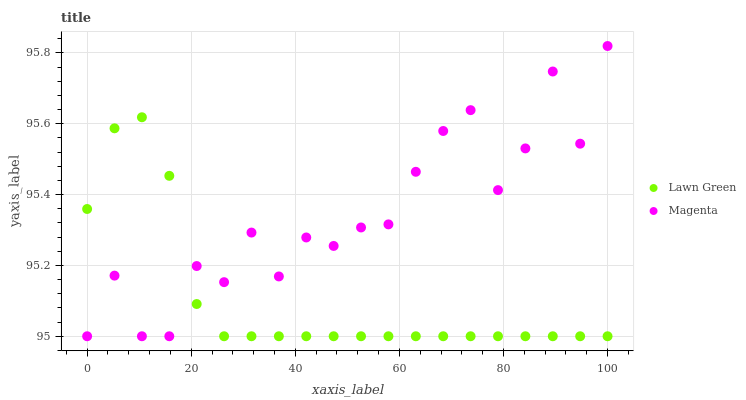Does Lawn Green have the minimum area under the curve?
Answer yes or no. Yes. Does Magenta have the maximum area under the curve?
Answer yes or no. Yes. Does Magenta have the minimum area under the curve?
Answer yes or no. No. Is Lawn Green the smoothest?
Answer yes or no. Yes. Is Magenta the roughest?
Answer yes or no. Yes. Is Magenta the smoothest?
Answer yes or no. No. Does Lawn Green have the lowest value?
Answer yes or no. Yes. Does Magenta have the highest value?
Answer yes or no. Yes. Does Magenta intersect Lawn Green?
Answer yes or no. Yes. Is Magenta less than Lawn Green?
Answer yes or no. No. Is Magenta greater than Lawn Green?
Answer yes or no. No. 